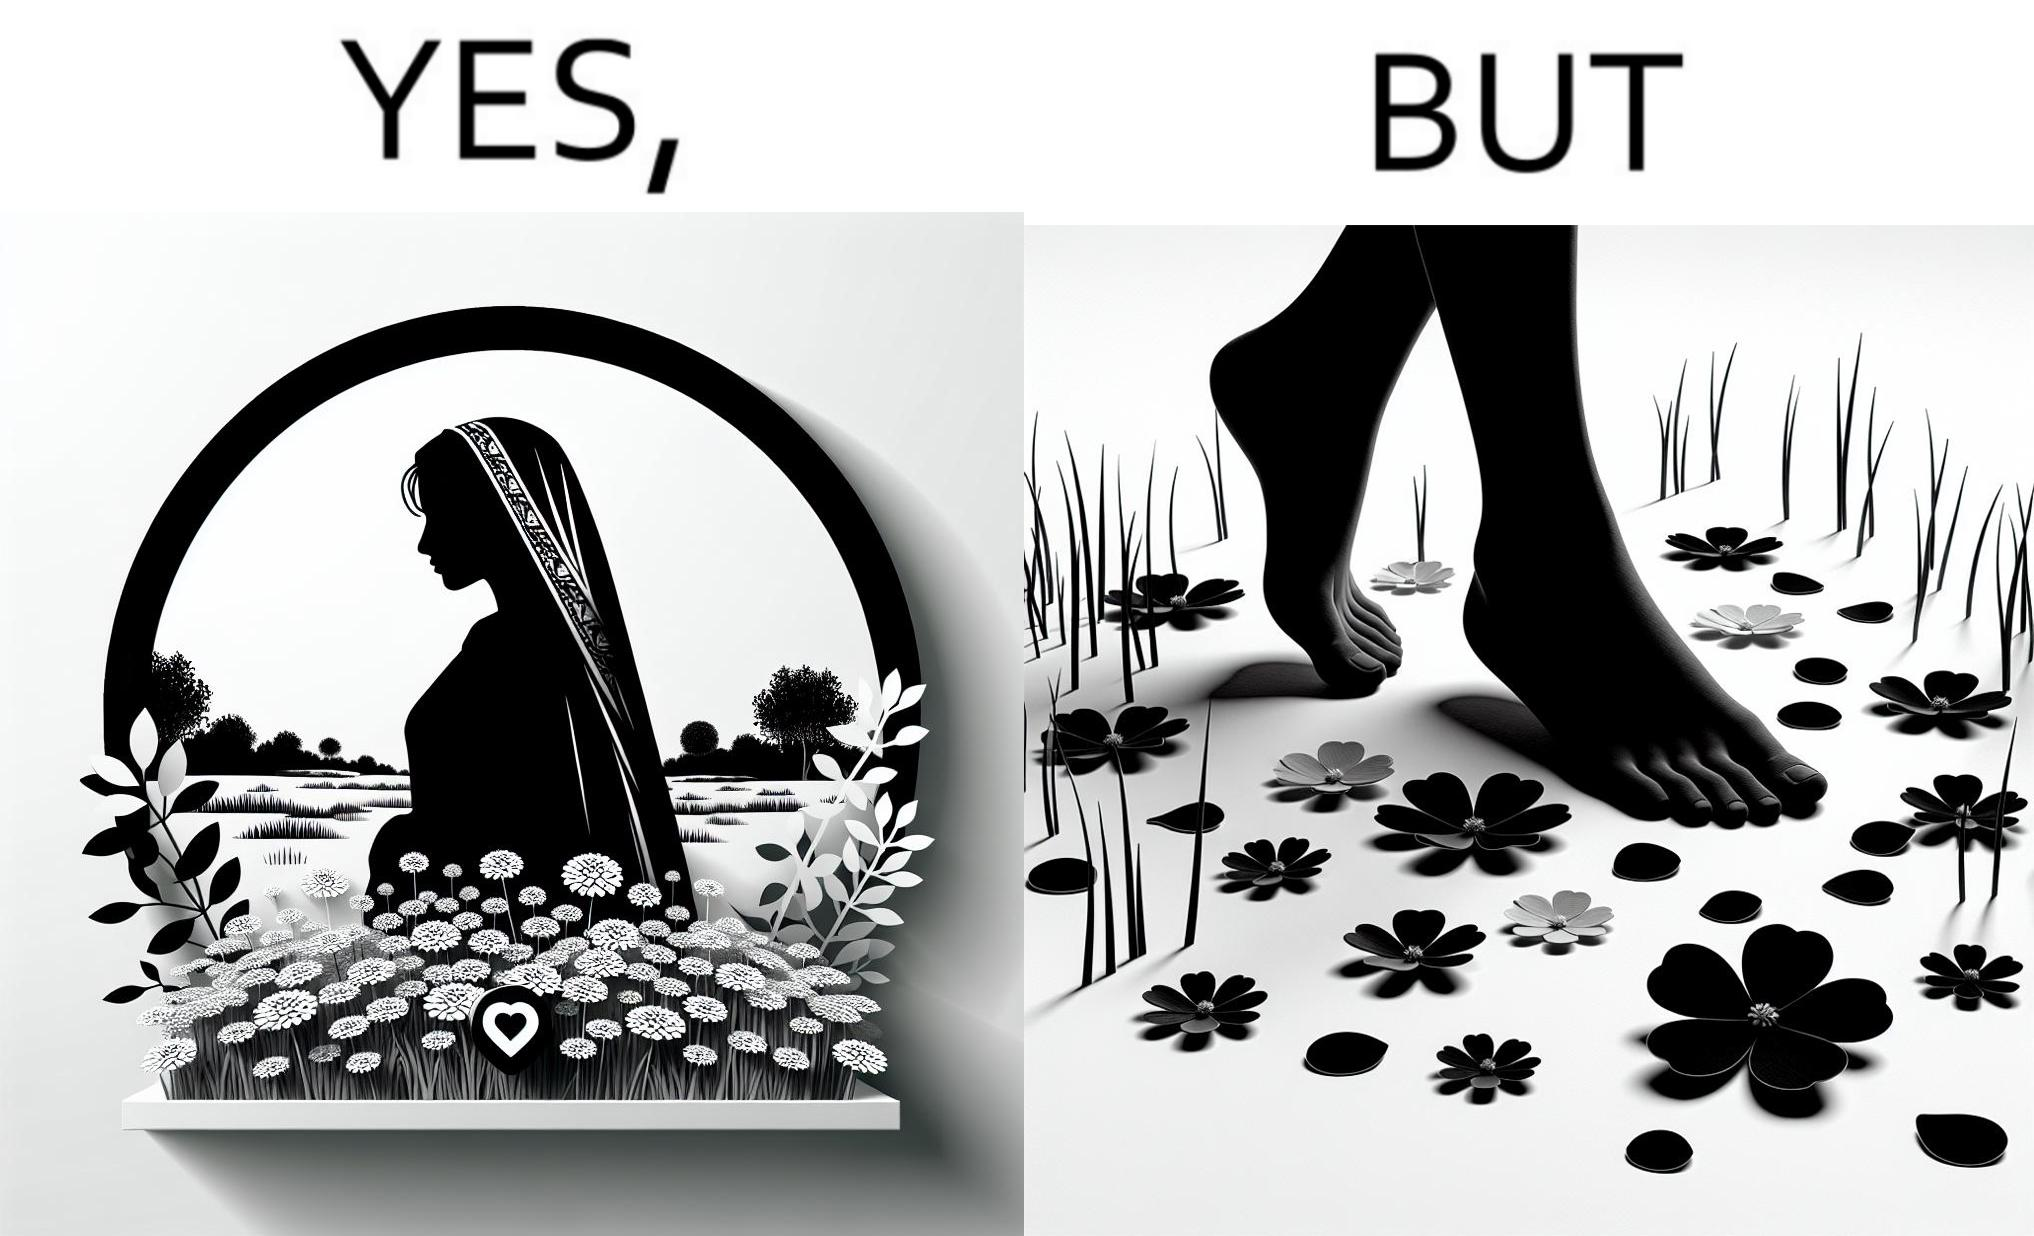Compare the left and right sides of this image. In the left part of the image: a social media post showing a woman in a field of flowers, with hashtags such as #naturelovers, #lovenature, #nature. In the right part of the image: feet stepping on flower petals surrounded by grass. 